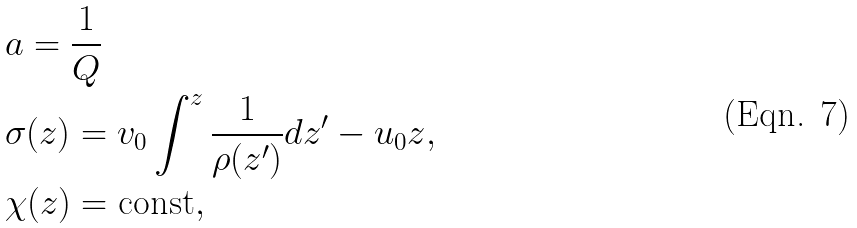Convert formula to latex. <formula><loc_0><loc_0><loc_500><loc_500>& a = \frac { 1 } { Q } \\ & \sigma ( z ) = { v _ { 0 } } \int ^ { z } \frac { 1 } { \rho ( z ^ { \prime } ) } d z ^ { \prime } - u _ { 0 } z , \\ & \chi ( z ) = \text {const} ,</formula> 